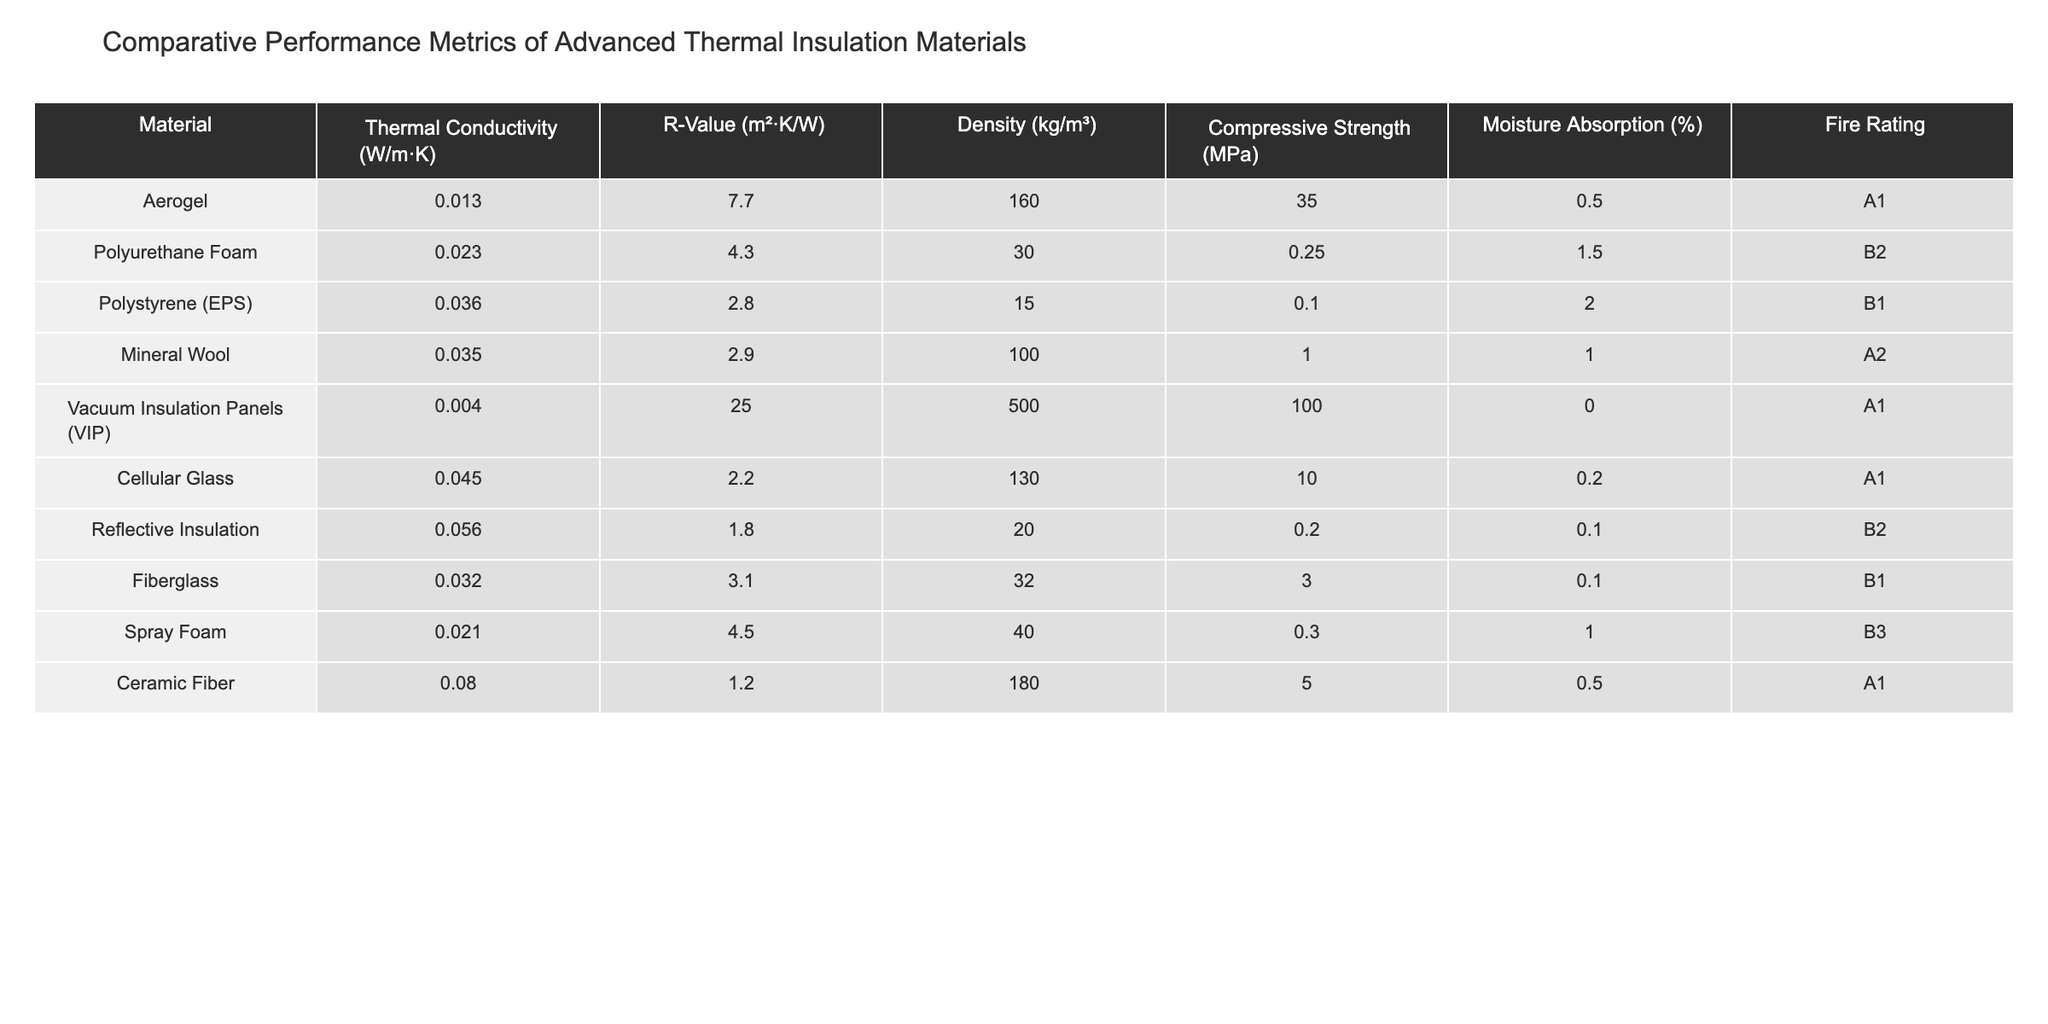What is the thermal conductivity of Aerogel? From the table, Aerogel has a thermal conductivity of 0.013 W/m·K as stated in the corresponding row for this material.
Answer: 0.013 W/m·K Which material has the highest R-Value? Looking at the R-Value column, Vacuum Insulation Panels (VIP) has the highest R-Value at 25 m²·K/W, as it is greater than all other listed materials.
Answer: 25 m²·K/W Is the density of Polyurethane Foam greater than that of Mineral Wool? In the table, Polyurethane Foam has a density of 30 kg/m³, while Mineral Wool has a density of 100 kg/m³. Since 30 < 100, the statement is false.
Answer: No What is the difference in compressive strength between Vacuum Insulation Panels and Cellular Glass? Vacuum Insulation Panels have a compressive strength of 100 MPa, while Cellular Glass has 10 MPa. The difference is calculated as 100 MPa - 10 MPa = 90 MPa.
Answer: 90 MPa Which materials have a fire rating of A1? By checking the fire rating column, we find that Aerogel, Vacuum Insulation Panels, Cellular Glass, and Ceramic Fiber all have a fire rating of A1.
Answer: Aerogel, Vacuum Insulation Panels, Cellular Glass, Ceramic Fiber What is the average density of the listed materials? The densities listed are 160, 30, 15, 100, 500, 130, 20, 32, and 180 kg/m³. The sum of these values is 1137 kg/m³, and there are 9 materials, so the average density is 1137/9 ≈ 126.33 kg/m³.
Answer: Approximately 126.33 kg/m³ Which material has the lowest moisture absorption and what is that value? Reviewing the moisture absorption percentages, Vacuum Insulation Panels (VIP) has the lowest value of 0.0%.
Answer: 0.0% What is the average R-value of the materials with a fire rating of B1? The materials with a B1 fire rating are Polystyrene (EPS), Fiberglass, and Spray Foam, with R-Values of 2.8, 3.1, and 4.5 respectively. Adding these gives 2.8 + 3.1 + 4.5 = 10.4, and averaging gives 10.4 / 3 ≈ 3.47.
Answer: Approximately 3.47 Which material has the highest density and what is its compressive strength? The highest density is found in Vacuum Insulation Panels at 500 kg/m³, which has a compressive strength of 100 MPa, as noted in the respective row.
Answer: 100 MPa Is the thermal conductivity of Ceramic Fiber higher than that of Fiberglass? Ceramic Fiber has a thermal conductivity of 0.080 W/m·K, while Fiberglass has 0.032 W/m·K. Since 0.080 > 0.032, the statement is true.
Answer: Yes What is the combined compressive strength of all materials with a fire rating of B2? The materials with a B2 fire rating are Polyurethane Foam (0.25 MPa) and Reflective Insulation (0.2 MPa). Adding them results in 0.25 + 0.2 = 0.45 MPa.
Answer: 0.45 MPa 